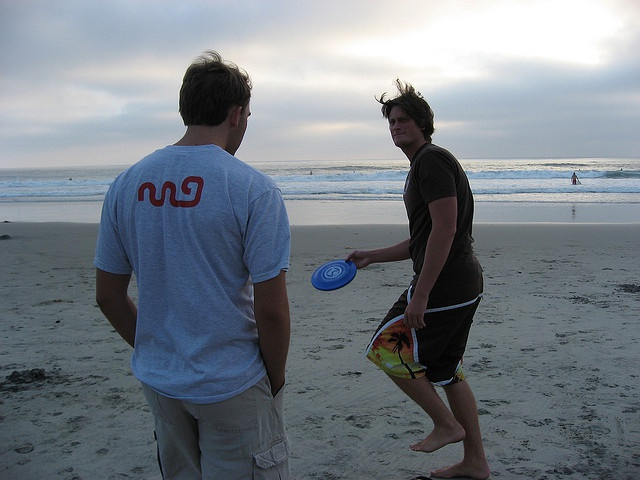Describe the objects in this image and their specific colors. I can see people in darkgray, darkblue, black, and gray tones, people in darkgray, black, gray, and darkgreen tones, and frisbee in darkgray, navy, blue, gray, and darkblue tones in this image. 